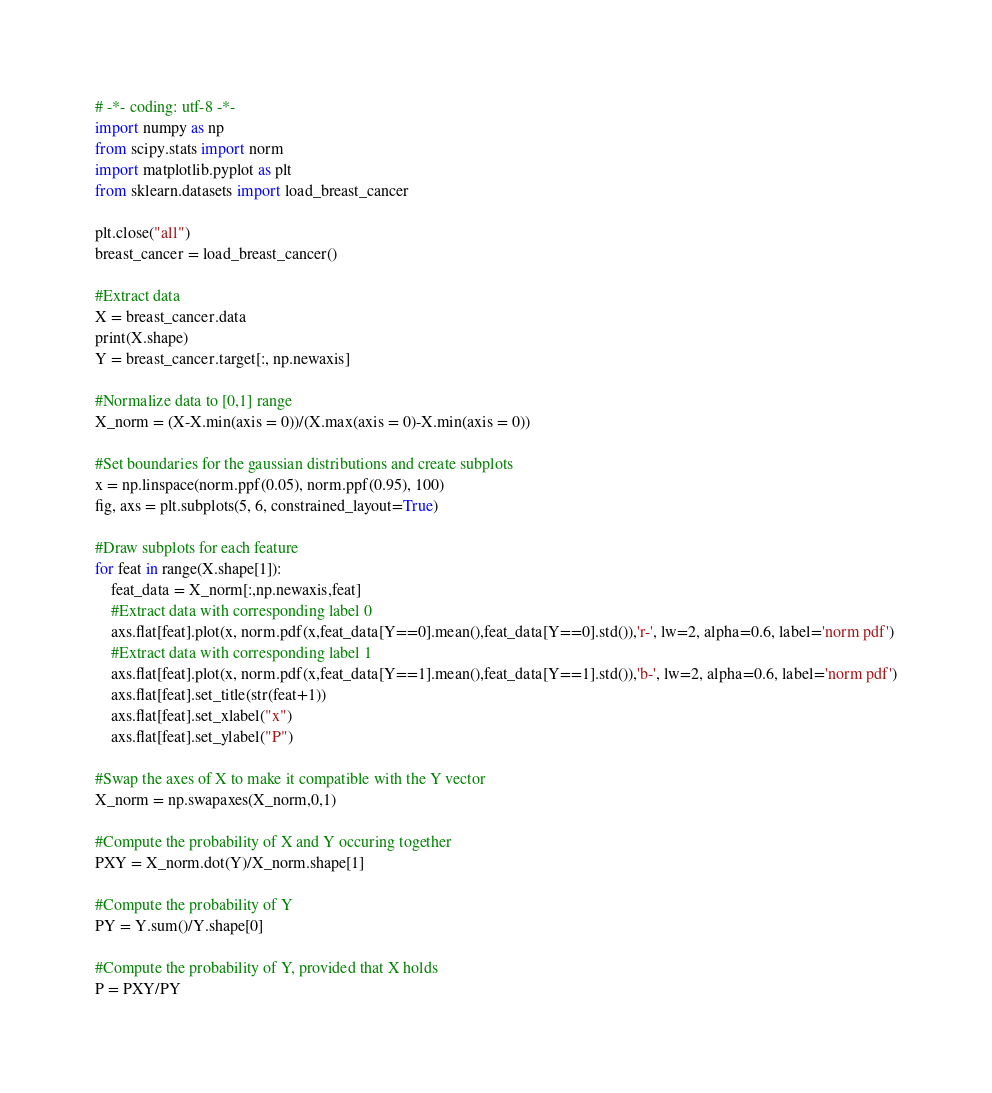Convert code to text. <code><loc_0><loc_0><loc_500><loc_500><_Python_># -*- coding: utf-8 -*-
import numpy as np
from scipy.stats import norm
import matplotlib.pyplot as plt
from sklearn.datasets import load_breast_cancer

plt.close("all")
breast_cancer = load_breast_cancer()

#Extract data
X = breast_cancer.data
print(X.shape)
Y = breast_cancer.target[:, np.newaxis]

#Normalize data to [0,1] range
X_norm = (X-X.min(axis = 0))/(X.max(axis = 0)-X.min(axis = 0))

#Set boundaries for the gaussian distributions and create subplots
x = np.linspace(norm.ppf(0.05), norm.ppf(0.95), 100)
fig, axs = plt.subplots(5, 6, constrained_layout=True)

#Draw subplots for each feature
for feat in range(X.shape[1]):
    feat_data = X_norm[:,np.newaxis,feat]
    #Extract data with corresponding label 0
    axs.flat[feat].plot(x, norm.pdf(x,feat_data[Y==0].mean(),feat_data[Y==0].std()),'r-', lw=2, alpha=0.6, label='norm pdf')
    #Extract data with corresponding label 1
    axs.flat[feat].plot(x, norm.pdf(x,feat_data[Y==1].mean(),feat_data[Y==1].std()),'b-', lw=2, alpha=0.6, label='norm pdf')
    axs.flat[feat].set_title(str(feat+1))
    axs.flat[feat].set_xlabel("x")
    axs.flat[feat].set_ylabel("P")

#Swap the axes of X to make it compatible with the Y vector
X_norm = np.swapaxes(X_norm,0,1)

#Compute the probability of X and Y occuring together
PXY = X_norm.dot(Y)/X_norm.shape[1]

#Compute the probability of Y
PY = Y.sum()/Y.shape[0]

#Compute the probability of Y, provided that X holds
P = PXY/PY
</code> 